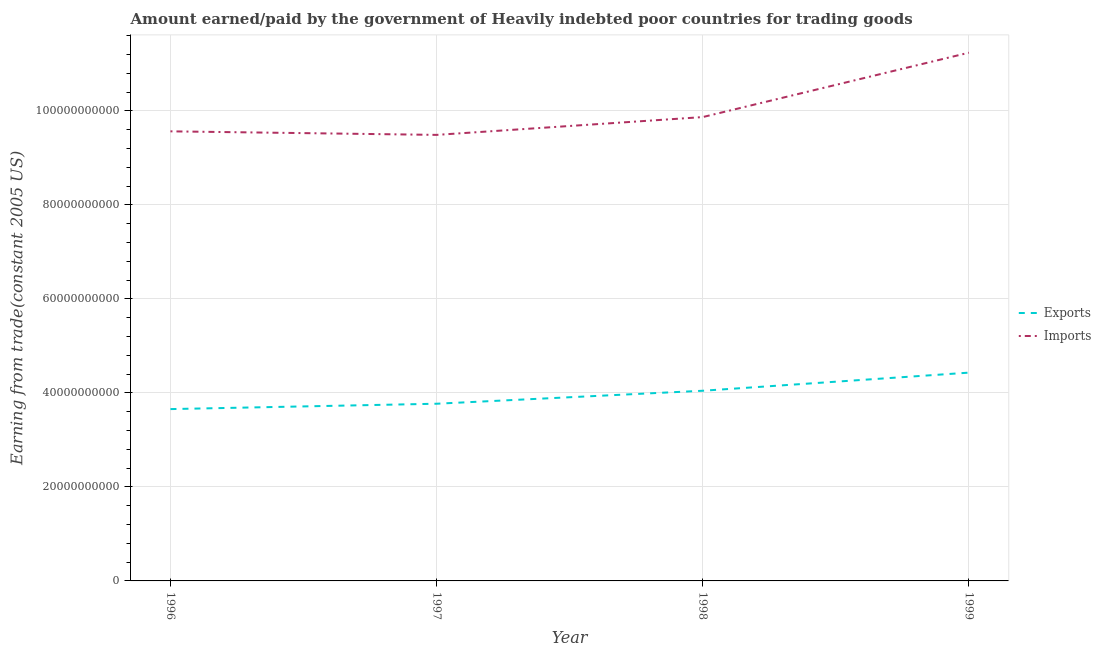How many different coloured lines are there?
Offer a terse response. 2. Does the line corresponding to amount paid for imports intersect with the line corresponding to amount earned from exports?
Ensure brevity in your answer.  No. What is the amount paid for imports in 1997?
Offer a terse response. 9.49e+1. Across all years, what is the maximum amount paid for imports?
Keep it short and to the point. 1.12e+11. Across all years, what is the minimum amount paid for imports?
Offer a terse response. 9.49e+1. What is the total amount earned from exports in the graph?
Offer a very short reply. 1.59e+11. What is the difference between the amount paid for imports in 1997 and that in 1998?
Keep it short and to the point. -3.79e+09. What is the difference between the amount earned from exports in 1997 and the amount paid for imports in 1996?
Your response must be concise. -5.80e+1. What is the average amount earned from exports per year?
Keep it short and to the point. 3.98e+1. In the year 1999, what is the difference between the amount earned from exports and amount paid for imports?
Provide a succinct answer. -6.81e+1. What is the ratio of the amount paid for imports in 1997 to that in 1999?
Your answer should be compact. 0.84. Is the difference between the amount earned from exports in 1998 and 1999 greater than the difference between the amount paid for imports in 1998 and 1999?
Your response must be concise. Yes. What is the difference between the highest and the second highest amount paid for imports?
Keep it short and to the point. 1.37e+1. What is the difference between the highest and the lowest amount paid for imports?
Give a very brief answer. 1.75e+1. Does the amount earned from exports monotonically increase over the years?
Offer a very short reply. Yes. Is the amount earned from exports strictly greater than the amount paid for imports over the years?
Offer a terse response. No. How many years are there in the graph?
Give a very brief answer. 4. What is the difference between two consecutive major ticks on the Y-axis?
Your response must be concise. 2.00e+1. Does the graph contain any zero values?
Your answer should be compact. No. Does the graph contain grids?
Offer a very short reply. Yes. How many legend labels are there?
Provide a succinct answer. 2. How are the legend labels stacked?
Keep it short and to the point. Vertical. What is the title of the graph?
Provide a succinct answer. Amount earned/paid by the government of Heavily indebted poor countries for trading goods. Does "Young" appear as one of the legend labels in the graph?
Your answer should be compact. No. What is the label or title of the Y-axis?
Provide a succinct answer. Earning from trade(constant 2005 US). What is the Earning from trade(constant 2005 US) in Exports in 1996?
Provide a succinct answer. 3.66e+1. What is the Earning from trade(constant 2005 US) in Imports in 1996?
Provide a short and direct response. 9.56e+1. What is the Earning from trade(constant 2005 US) in Exports in 1997?
Offer a terse response. 3.77e+1. What is the Earning from trade(constant 2005 US) in Imports in 1997?
Your response must be concise. 9.49e+1. What is the Earning from trade(constant 2005 US) in Exports in 1998?
Your answer should be very brief. 4.05e+1. What is the Earning from trade(constant 2005 US) in Imports in 1998?
Your answer should be compact. 9.87e+1. What is the Earning from trade(constant 2005 US) in Exports in 1999?
Offer a very short reply. 4.43e+1. What is the Earning from trade(constant 2005 US) in Imports in 1999?
Your response must be concise. 1.12e+11. Across all years, what is the maximum Earning from trade(constant 2005 US) of Exports?
Offer a terse response. 4.43e+1. Across all years, what is the maximum Earning from trade(constant 2005 US) of Imports?
Provide a short and direct response. 1.12e+11. Across all years, what is the minimum Earning from trade(constant 2005 US) of Exports?
Offer a very short reply. 3.66e+1. Across all years, what is the minimum Earning from trade(constant 2005 US) in Imports?
Your response must be concise. 9.49e+1. What is the total Earning from trade(constant 2005 US) in Exports in the graph?
Your answer should be very brief. 1.59e+11. What is the total Earning from trade(constant 2005 US) of Imports in the graph?
Provide a short and direct response. 4.02e+11. What is the difference between the Earning from trade(constant 2005 US) in Exports in 1996 and that in 1997?
Provide a succinct answer. -1.14e+09. What is the difference between the Earning from trade(constant 2005 US) of Imports in 1996 and that in 1997?
Your response must be concise. 7.55e+08. What is the difference between the Earning from trade(constant 2005 US) of Exports in 1996 and that in 1998?
Your answer should be compact. -3.90e+09. What is the difference between the Earning from trade(constant 2005 US) of Imports in 1996 and that in 1998?
Provide a short and direct response. -3.03e+09. What is the difference between the Earning from trade(constant 2005 US) of Exports in 1996 and that in 1999?
Keep it short and to the point. -7.75e+09. What is the difference between the Earning from trade(constant 2005 US) of Imports in 1996 and that in 1999?
Provide a succinct answer. -1.67e+1. What is the difference between the Earning from trade(constant 2005 US) of Exports in 1997 and that in 1998?
Provide a short and direct response. -2.76e+09. What is the difference between the Earning from trade(constant 2005 US) in Imports in 1997 and that in 1998?
Keep it short and to the point. -3.79e+09. What is the difference between the Earning from trade(constant 2005 US) of Exports in 1997 and that in 1999?
Ensure brevity in your answer.  -6.61e+09. What is the difference between the Earning from trade(constant 2005 US) in Imports in 1997 and that in 1999?
Provide a succinct answer. -1.75e+1. What is the difference between the Earning from trade(constant 2005 US) of Exports in 1998 and that in 1999?
Offer a very short reply. -3.85e+09. What is the difference between the Earning from trade(constant 2005 US) of Imports in 1998 and that in 1999?
Provide a succinct answer. -1.37e+1. What is the difference between the Earning from trade(constant 2005 US) of Exports in 1996 and the Earning from trade(constant 2005 US) of Imports in 1997?
Provide a succinct answer. -5.83e+1. What is the difference between the Earning from trade(constant 2005 US) in Exports in 1996 and the Earning from trade(constant 2005 US) in Imports in 1998?
Give a very brief answer. -6.21e+1. What is the difference between the Earning from trade(constant 2005 US) in Exports in 1996 and the Earning from trade(constant 2005 US) in Imports in 1999?
Give a very brief answer. -7.58e+1. What is the difference between the Earning from trade(constant 2005 US) in Exports in 1997 and the Earning from trade(constant 2005 US) in Imports in 1998?
Offer a very short reply. -6.10e+1. What is the difference between the Earning from trade(constant 2005 US) in Exports in 1997 and the Earning from trade(constant 2005 US) in Imports in 1999?
Your response must be concise. -7.47e+1. What is the difference between the Earning from trade(constant 2005 US) in Exports in 1998 and the Earning from trade(constant 2005 US) in Imports in 1999?
Your answer should be compact. -7.19e+1. What is the average Earning from trade(constant 2005 US) in Exports per year?
Your response must be concise. 3.98e+1. What is the average Earning from trade(constant 2005 US) of Imports per year?
Offer a very short reply. 1.00e+11. In the year 1996, what is the difference between the Earning from trade(constant 2005 US) in Exports and Earning from trade(constant 2005 US) in Imports?
Ensure brevity in your answer.  -5.91e+1. In the year 1997, what is the difference between the Earning from trade(constant 2005 US) of Exports and Earning from trade(constant 2005 US) of Imports?
Give a very brief answer. -5.72e+1. In the year 1998, what is the difference between the Earning from trade(constant 2005 US) of Exports and Earning from trade(constant 2005 US) of Imports?
Give a very brief answer. -5.82e+1. In the year 1999, what is the difference between the Earning from trade(constant 2005 US) in Exports and Earning from trade(constant 2005 US) in Imports?
Your answer should be compact. -6.81e+1. What is the ratio of the Earning from trade(constant 2005 US) of Exports in 1996 to that in 1997?
Your response must be concise. 0.97. What is the ratio of the Earning from trade(constant 2005 US) in Imports in 1996 to that in 1997?
Provide a succinct answer. 1.01. What is the ratio of the Earning from trade(constant 2005 US) of Exports in 1996 to that in 1998?
Offer a terse response. 0.9. What is the ratio of the Earning from trade(constant 2005 US) in Imports in 1996 to that in 1998?
Your answer should be very brief. 0.97. What is the ratio of the Earning from trade(constant 2005 US) of Exports in 1996 to that in 1999?
Provide a short and direct response. 0.82. What is the ratio of the Earning from trade(constant 2005 US) of Imports in 1996 to that in 1999?
Keep it short and to the point. 0.85. What is the ratio of the Earning from trade(constant 2005 US) of Exports in 1997 to that in 1998?
Your answer should be very brief. 0.93. What is the ratio of the Earning from trade(constant 2005 US) of Imports in 1997 to that in 1998?
Give a very brief answer. 0.96. What is the ratio of the Earning from trade(constant 2005 US) of Exports in 1997 to that in 1999?
Keep it short and to the point. 0.85. What is the ratio of the Earning from trade(constant 2005 US) of Imports in 1997 to that in 1999?
Ensure brevity in your answer.  0.84. What is the ratio of the Earning from trade(constant 2005 US) in Exports in 1998 to that in 1999?
Ensure brevity in your answer.  0.91. What is the ratio of the Earning from trade(constant 2005 US) in Imports in 1998 to that in 1999?
Keep it short and to the point. 0.88. What is the difference between the highest and the second highest Earning from trade(constant 2005 US) in Exports?
Make the answer very short. 3.85e+09. What is the difference between the highest and the second highest Earning from trade(constant 2005 US) of Imports?
Offer a very short reply. 1.37e+1. What is the difference between the highest and the lowest Earning from trade(constant 2005 US) of Exports?
Ensure brevity in your answer.  7.75e+09. What is the difference between the highest and the lowest Earning from trade(constant 2005 US) in Imports?
Ensure brevity in your answer.  1.75e+1. 